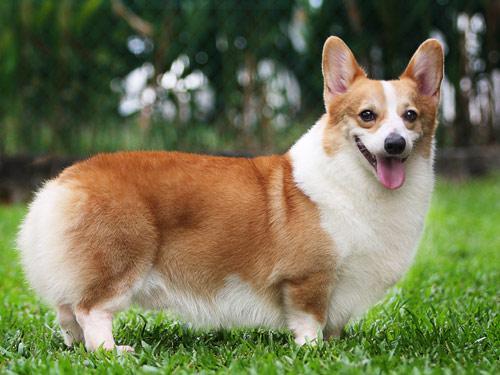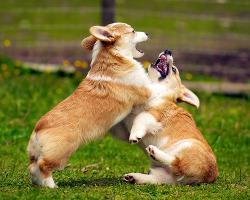The first image is the image on the left, the second image is the image on the right. Assess this claim about the two images: "An image shows a forward-facing dog with its mouth closed.". Correct or not? Answer yes or no. No. The first image is the image on the left, the second image is the image on the right. Examine the images to the left and right. Is the description "There is exactly two dogs in the right image." accurate? Answer yes or no. Yes. 